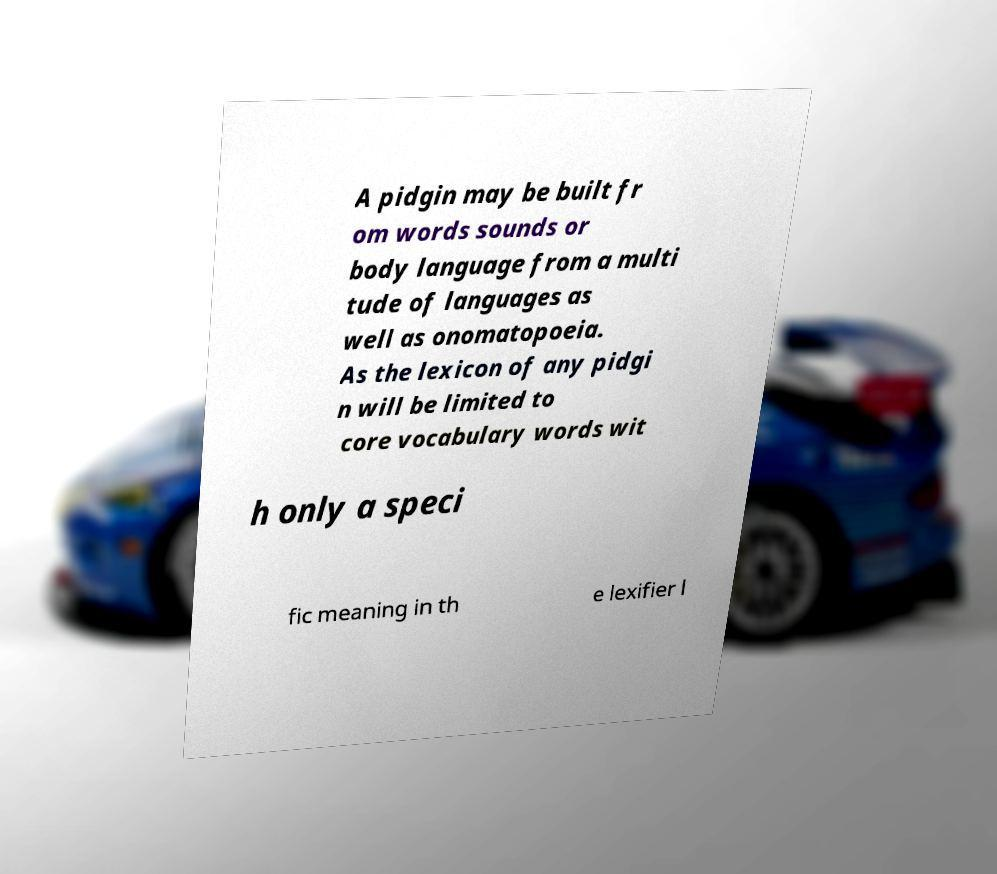What messages or text are displayed in this image? I need them in a readable, typed format. A pidgin may be built fr om words sounds or body language from a multi tude of languages as well as onomatopoeia. As the lexicon of any pidgi n will be limited to core vocabulary words wit h only a speci fic meaning in th e lexifier l 